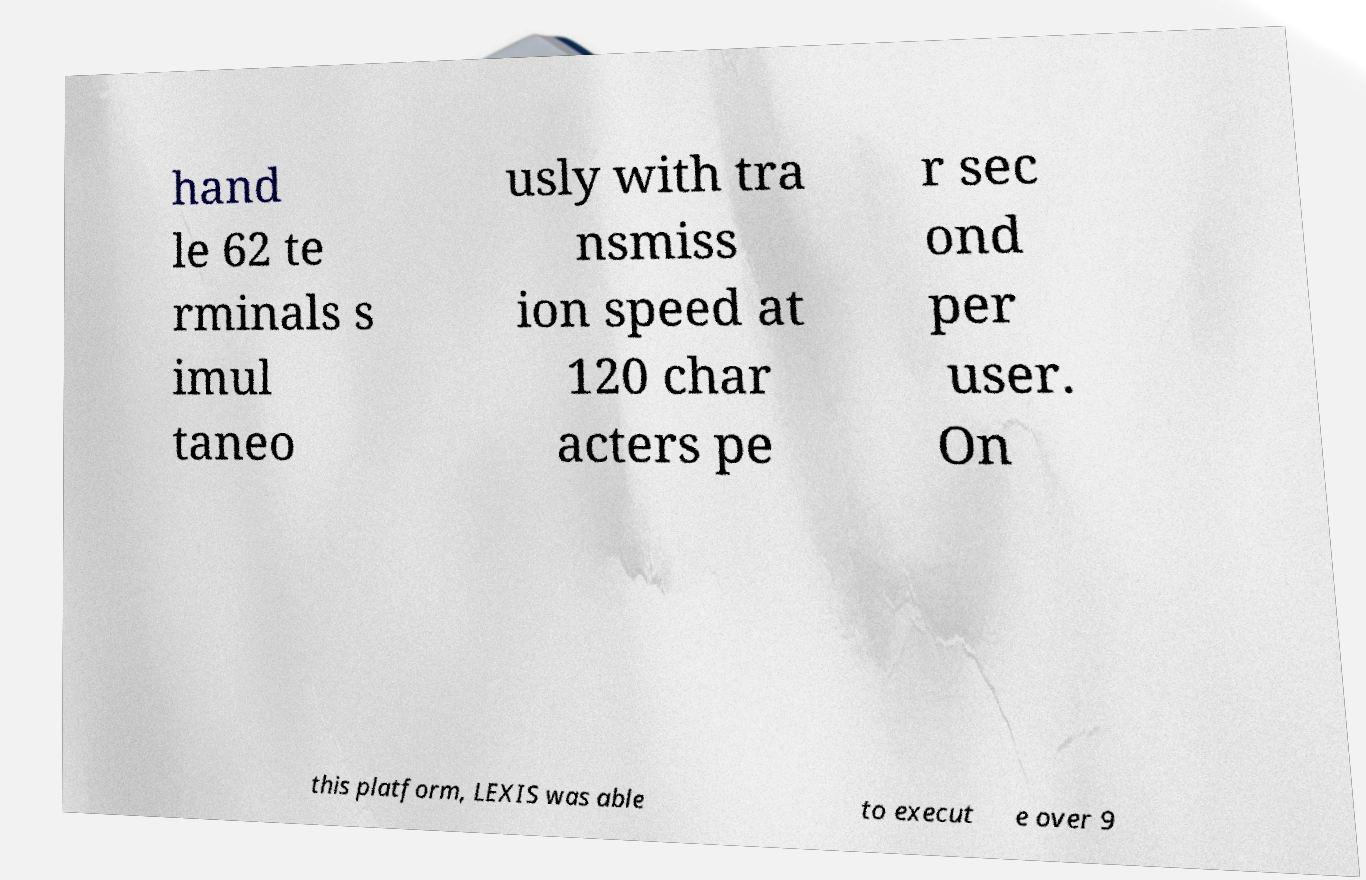For documentation purposes, I need the text within this image transcribed. Could you provide that? hand le 62 te rminals s imul taneo usly with tra nsmiss ion speed at 120 char acters pe r sec ond per user. On this platform, LEXIS was able to execut e over 9 